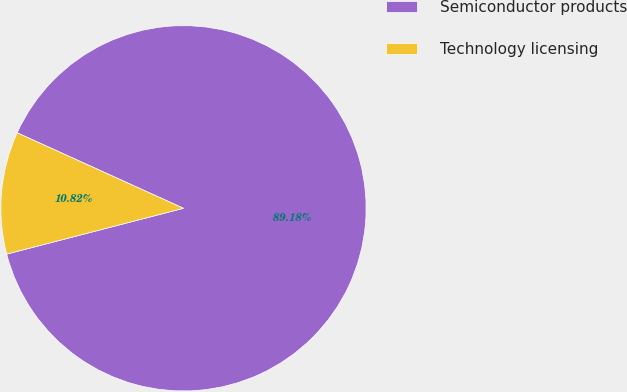<chart> <loc_0><loc_0><loc_500><loc_500><pie_chart><fcel>Semiconductor products<fcel>Technology licensing<nl><fcel>89.18%<fcel>10.82%<nl></chart> 